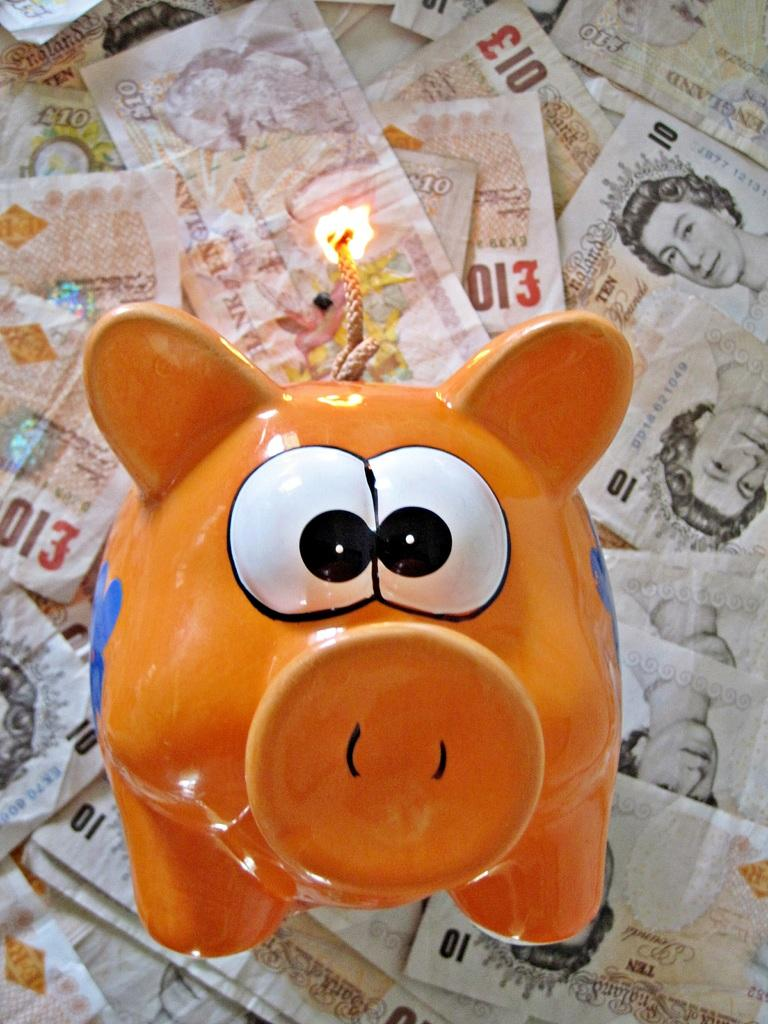What is the main subject in the middle of the image? There is a toy in the middle of the image. What else can be seen in the background of the image? Currency notes are visible in the background of the image. What type of clouds can be seen in the image? There are no clouds visible in the image; it only features a toy and currency notes. 